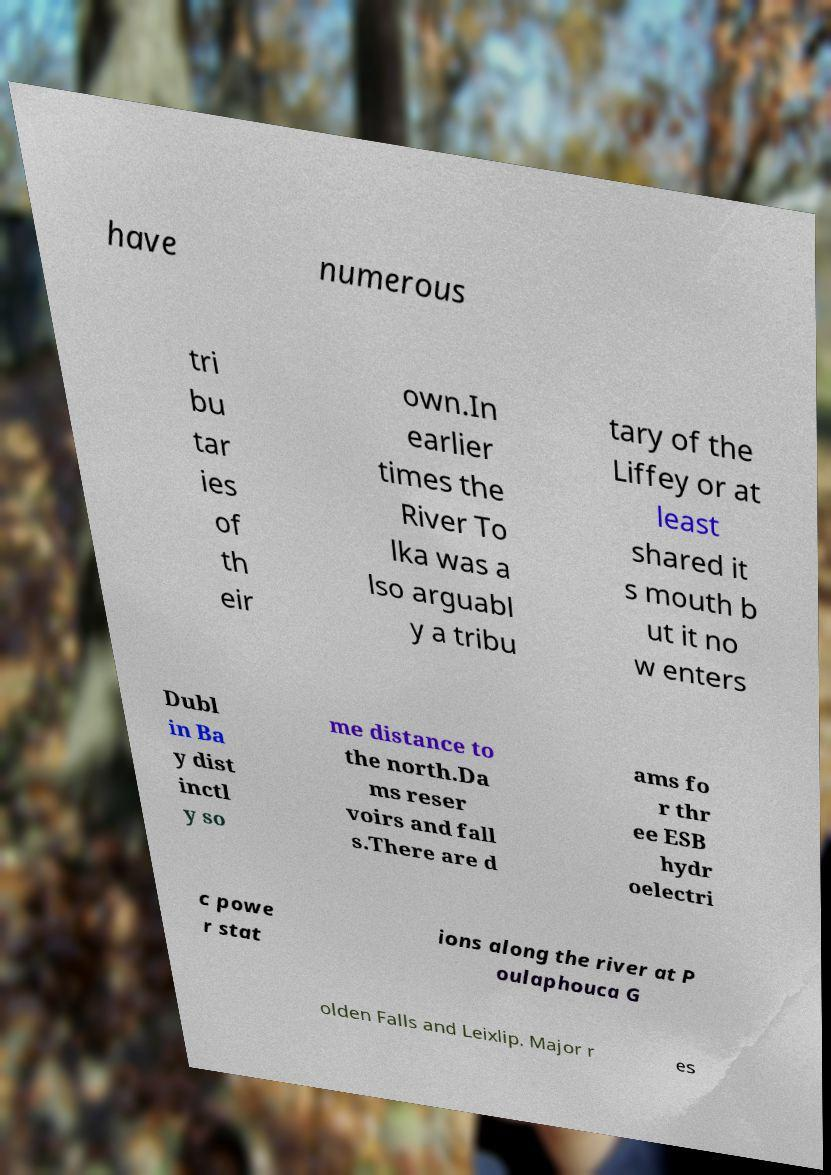There's text embedded in this image that I need extracted. Can you transcribe it verbatim? have numerous tri bu tar ies of th eir own.In earlier times the River To lka was a lso arguabl y a tribu tary of the Liffey or at least shared it s mouth b ut it no w enters Dubl in Ba y dist inctl y so me distance to the north.Da ms reser voirs and fall s.There are d ams fo r thr ee ESB hydr oelectri c powe r stat ions along the river at P oulaphouca G olden Falls and Leixlip. Major r es 